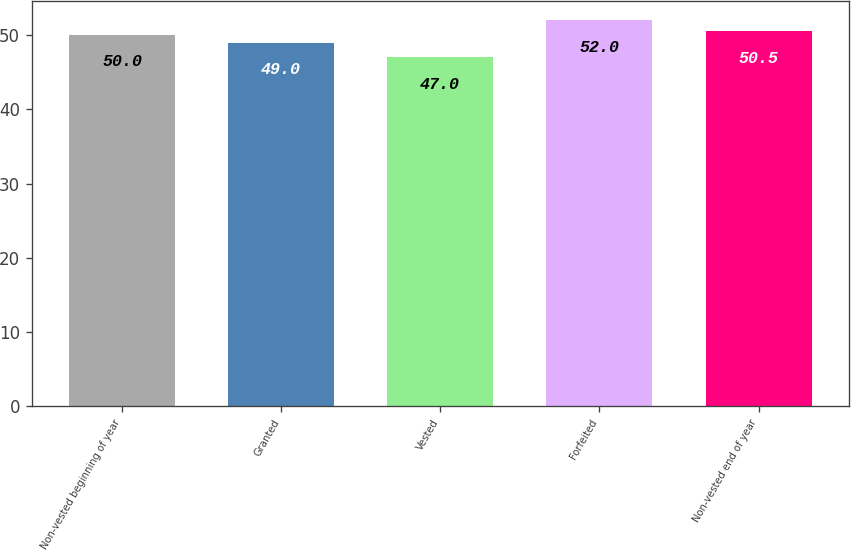Convert chart to OTSL. <chart><loc_0><loc_0><loc_500><loc_500><bar_chart><fcel>Non-vested beginning of year<fcel>Granted<fcel>Vested<fcel>Forfeited<fcel>Non-vested end of year<nl><fcel>50<fcel>49<fcel>47<fcel>52<fcel>50.5<nl></chart> 